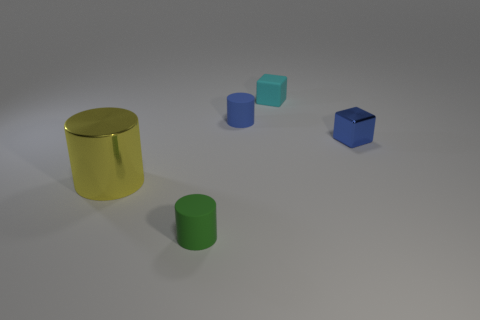There is another matte object that is the same shape as the tiny blue matte thing; what color is it?
Give a very brief answer. Green. Are there an equal number of blue objects on the left side of the tiny green rubber cylinder and matte cubes?
Your response must be concise. No. How many cylinders are both on the right side of the large cylinder and to the left of the tiny blue matte object?
Your response must be concise. 1. There is another object that is the same shape as the cyan object; what size is it?
Ensure brevity in your answer.  Small. What number of small blue things have the same material as the small blue block?
Ensure brevity in your answer.  0. Is the number of metal cylinders behind the rubber block less than the number of large cylinders?
Your response must be concise. Yes. How many tiny gray metallic cubes are there?
Provide a short and direct response. 0. What number of large metal things are the same color as the small metal object?
Your answer should be compact. 0. Do the blue metallic object and the tiny cyan object have the same shape?
Your answer should be compact. Yes. There is a matte cylinder that is behind the small matte thing in front of the yellow cylinder; what is its size?
Make the answer very short. Small. 